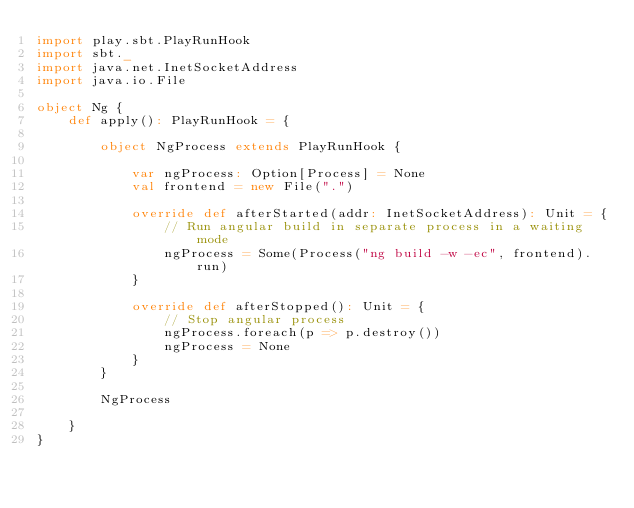<code> <loc_0><loc_0><loc_500><loc_500><_Scala_>import play.sbt.PlayRunHook
import sbt._
import java.net.InetSocketAddress
import java.io.File

object Ng {
    def apply(): PlayRunHook = {

        object NgProcess extends PlayRunHook {

            var ngProcess: Option[Process] = None
            val frontend = new File(".")

            override def afterStarted(addr: InetSocketAddress): Unit = {
                // Run angular build in separate process in a waiting mode
                ngProcess = Some(Process("ng build -w -ec", frontend).run)
            }

            override def afterStopped(): Unit = {
                // Stop angular process
                ngProcess.foreach(p => p.destroy())
                ngProcess = None
            }
        }

        NgProcess

    }
}</code> 